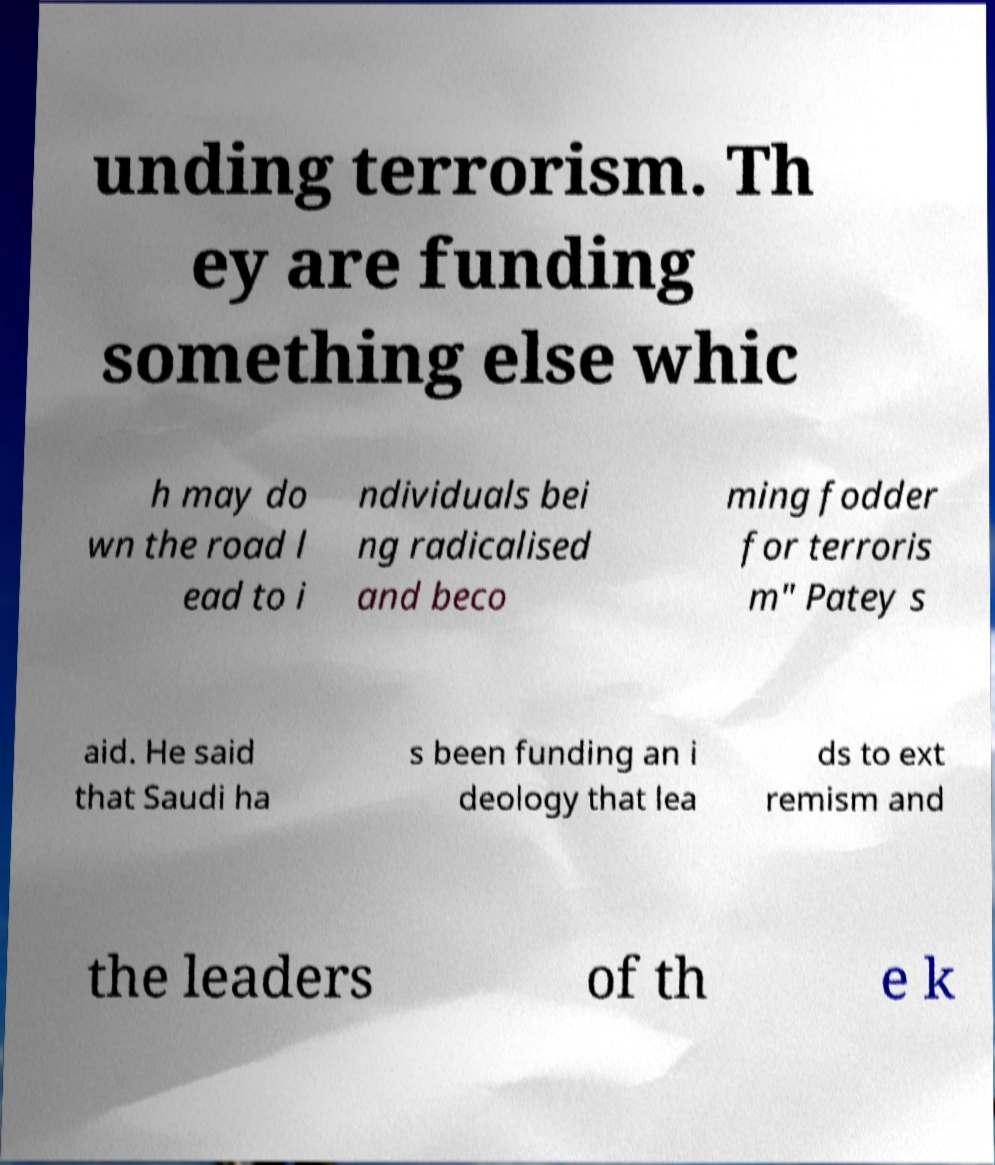Please identify and transcribe the text found in this image. unding terrorism. Th ey are funding something else whic h may do wn the road l ead to i ndividuals bei ng radicalised and beco ming fodder for terroris m" Patey s aid. He said that Saudi ha s been funding an i deology that lea ds to ext remism and the leaders of th e k 